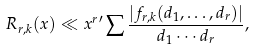<formula> <loc_0><loc_0><loc_500><loc_500>R _ { r , k } ( x ) \ll x ^ { r } { ^ { \prime } } \sum \frac { | f _ { r , k } ( d _ { 1 } , \dots , d _ { r } ) | } { d _ { 1 } \cdots d _ { r } } ,</formula> 